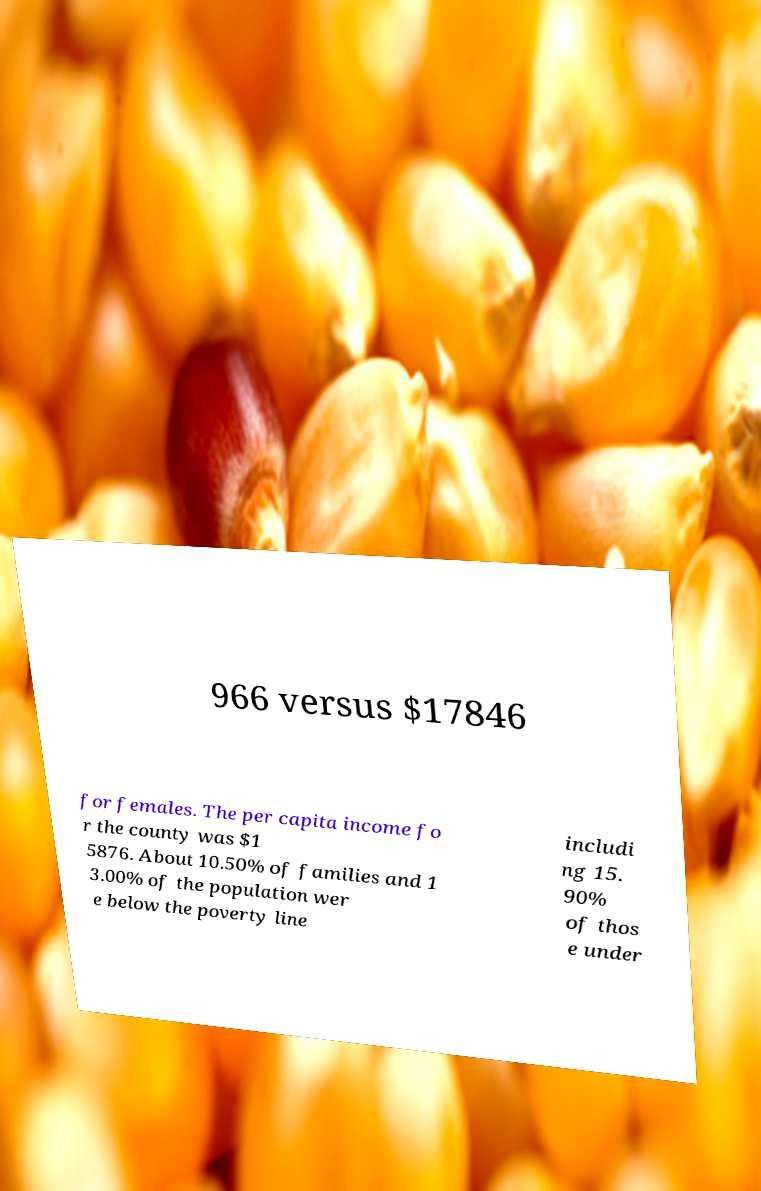Can you accurately transcribe the text from the provided image for me? 966 versus $17846 for females. The per capita income fo r the county was $1 5876. About 10.50% of families and 1 3.00% of the population wer e below the poverty line includi ng 15. 90% of thos e under 